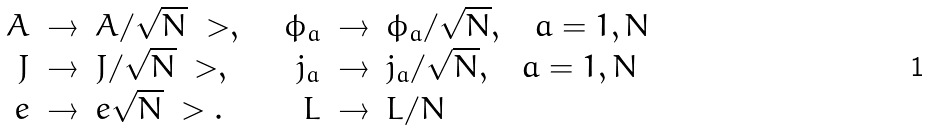<formula> <loc_0><loc_0><loc_500><loc_500>\begin{array} { r c l r c l } A & \rightarrow & A / \sqrt { N } \ > , \quad & \phi _ { a } & \rightarrow & \phi _ { a } / \sqrt { N } , \quad a = 1 , N \\ J & \rightarrow & J / \sqrt { N } \ > , \quad & j _ { a } & \rightarrow & j _ { a } / \sqrt { N } , \quad a = 1 , N \\ e & \rightarrow & e \sqrt { N } \ > . \quad & L & \rightarrow & L / N \end{array} \\</formula> 